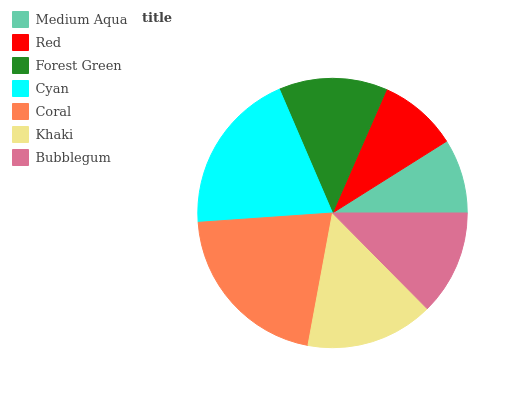Is Medium Aqua the minimum?
Answer yes or no. Yes. Is Coral the maximum?
Answer yes or no. Yes. Is Red the minimum?
Answer yes or no. No. Is Red the maximum?
Answer yes or no. No. Is Red greater than Medium Aqua?
Answer yes or no. Yes. Is Medium Aqua less than Red?
Answer yes or no. Yes. Is Medium Aqua greater than Red?
Answer yes or no. No. Is Red less than Medium Aqua?
Answer yes or no. No. Is Forest Green the high median?
Answer yes or no. Yes. Is Forest Green the low median?
Answer yes or no. Yes. Is Cyan the high median?
Answer yes or no. No. Is Red the low median?
Answer yes or no. No. 